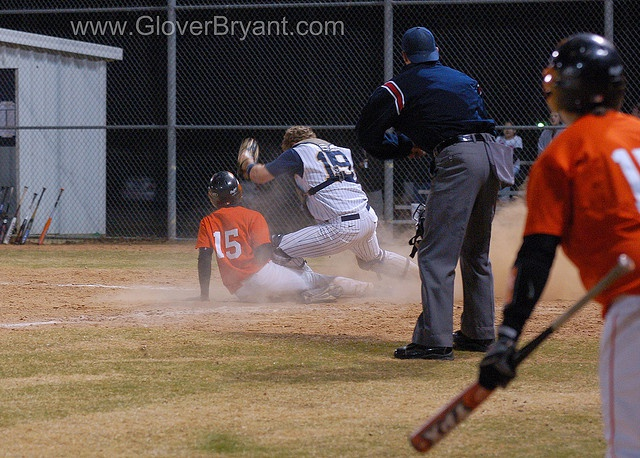Describe the objects in this image and their specific colors. I can see people in black, maroon, and gray tones, people in black, navy, and gray tones, people in black, darkgray, lavender, and gray tones, people in black, darkgray, brown, gray, and salmon tones, and baseball bat in black, maroon, and gray tones in this image. 